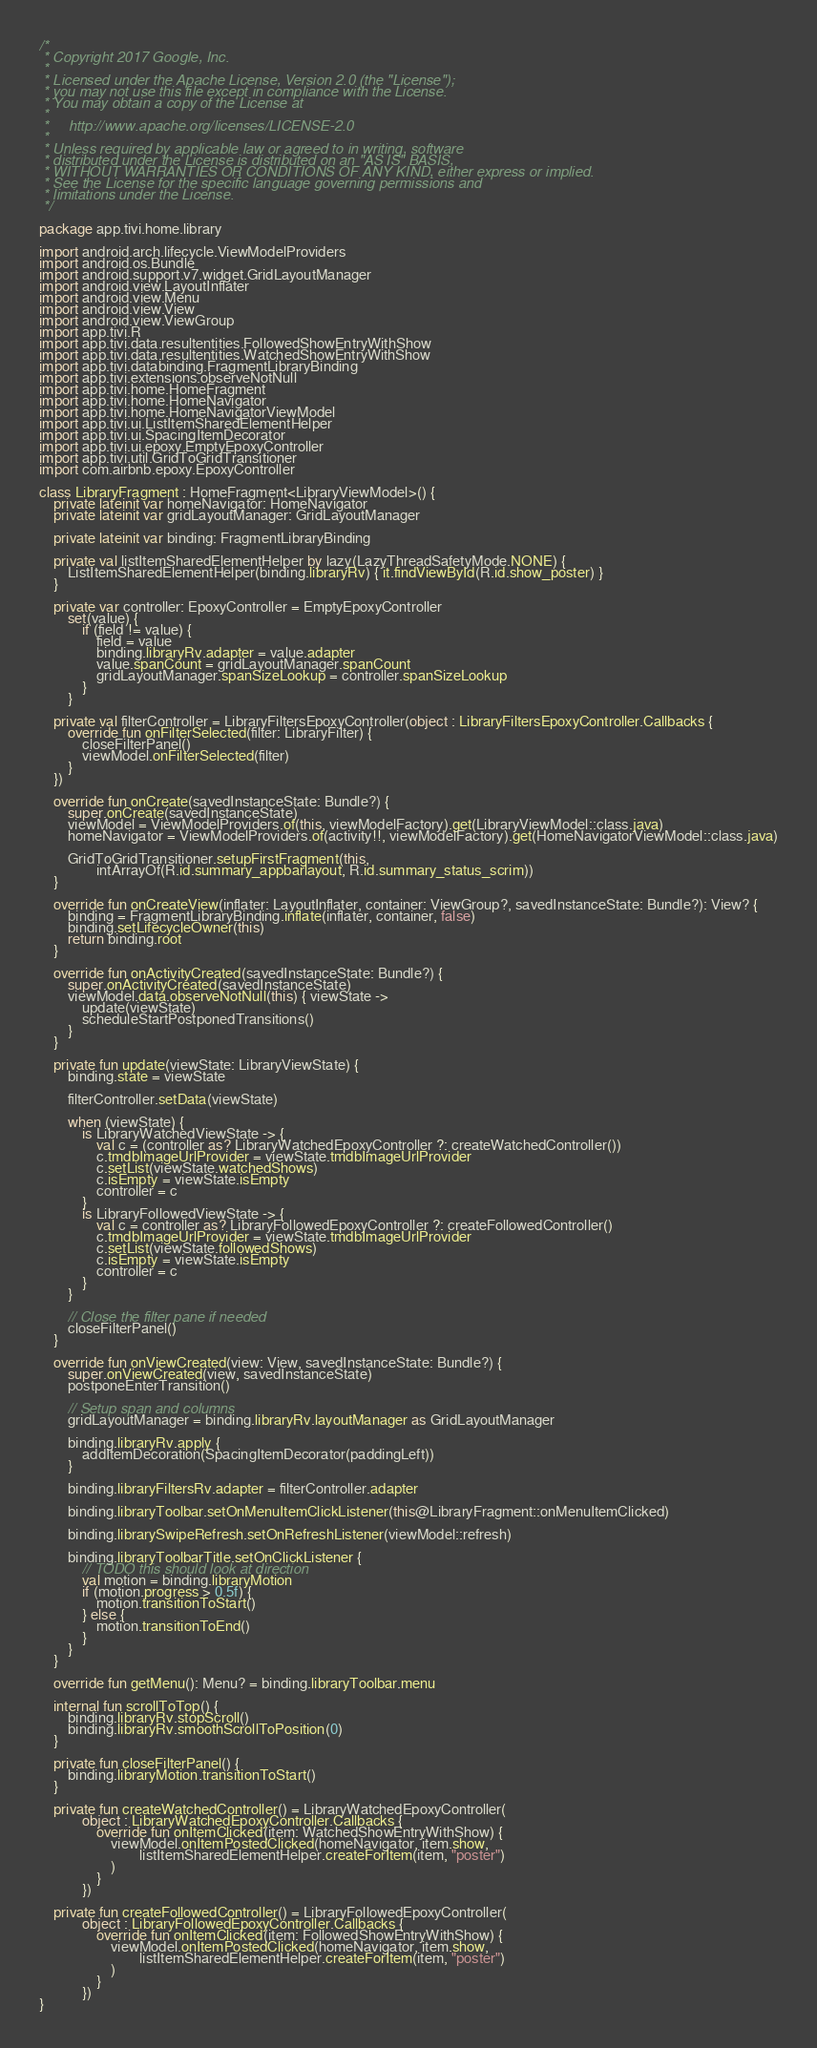<code> <loc_0><loc_0><loc_500><loc_500><_Kotlin_>/*
 * Copyright 2017 Google, Inc.
 *
 * Licensed under the Apache License, Version 2.0 (the "License");
 * you may not use this file except in compliance with the License.
 * You may obtain a copy of the License at
 *
 *     http://www.apache.org/licenses/LICENSE-2.0
 *
 * Unless required by applicable law or agreed to in writing, software
 * distributed under the License is distributed on an "AS IS" BASIS,
 * WITHOUT WARRANTIES OR CONDITIONS OF ANY KIND, either express or implied.
 * See the License for the specific language governing permissions and
 * limitations under the License.
 */

package app.tivi.home.library

import android.arch.lifecycle.ViewModelProviders
import android.os.Bundle
import android.support.v7.widget.GridLayoutManager
import android.view.LayoutInflater
import android.view.Menu
import android.view.View
import android.view.ViewGroup
import app.tivi.R
import app.tivi.data.resultentities.FollowedShowEntryWithShow
import app.tivi.data.resultentities.WatchedShowEntryWithShow
import app.tivi.databinding.FragmentLibraryBinding
import app.tivi.extensions.observeNotNull
import app.tivi.home.HomeFragment
import app.tivi.home.HomeNavigator
import app.tivi.home.HomeNavigatorViewModel
import app.tivi.ui.ListItemSharedElementHelper
import app.tivi.ui.SpacingItemDecorator
import app.tivi.ui.epoxy.EmptyEpoxyController
import app.tivi.util.GridToGridTransitioner
import com.airbnb.epoxy.EpoxyController

class LibraryFragment : HomeFragment<LibraryViewModel>() {
    private lateinit var homeNavigator: HomeNavigator
    private lateinit var gridLayoutManager: GridLayoutManager

    private lateinit var binding: FragmentLibraryBinding

    private val listItemSharedElementHelper by lazy(LazyThreadSafetyMode.NONE) {
        ListItemSharedElementHelper(binding.libraryRv) { it.findViewById(R.id.show_poster) }
    }

    private var controller: EpoxyController = EmptyEpoxyController
        set(value) {
            if (field != value) {
                field = value
                binding.libraryRv.adapter = value.adapter
                value.spanCount = gridLayoutManager.spanCount
                gridLayoutManager.spanSizeLookup = controller.spanSizeLookup
            }
        }

    private val filterController = LibraryFiltersEpoxyController(object : LibraryFiltersEpoxyController.Callbacks {
        override fun onFilterSelected(filter: LibraryFilter) {
            closeFilterPanel()
            viewModel.onFilterSelected(filter)
        }
    })

    override fun onCreate(savedInstanceState: Bundle?) {
        super.onCreate(savedInstanceState)
        viewModel = ViewModelProviders.of(this, viewModelFactory).get(LibraryViewModel::class.java)
        homeNavigator = ViewModelProviders.of(activity!!, viewModelFactory).get(HomeNavigatorViewModel::class.java)

        GridToGridTransitioner.setupFirstFragment(this,
                intArrayOf(R.id.summary_appbarlayout, R.id.summary_status_scrim))
    }

    override fun onCreateView(inflater: LayoutInflater, container: ViewGroup?, savedInstanceState: Bundle?): View? {
        binding = FragmentLibraryBinding.inflate(inflater, container, false)
        binding.setLifecycleOwner(this)
        return binding.root
    }

    override fun onActivityCreated(savedInstanceState: Bundle?) {
        super.onActivityCreated(savedInstanceState)
        viewModel.data.observeNotNull(this) { viewState ->
            update(viewState)
            scheduleStartPostponedTransitions()
        }
    }

    private fun update(viewState: LibraryViewState) {
        binding.state = viewState

        filterController.setData(viewState)

        when (viewState) {
            is LibraryWatchedViewState -> {
                val c = (controller as? LibraryWatchedEpoxyController ?: createWatchedController())
                c.tmdbImageUrlProvider = viewState.tmdbImageUrlProvider
                c.setList(viewState.watchedShows)
                c.isEmpty = viewState.isEmpty
                controller = c
            }
            is LibraryFollowedViewState -> {
                val c = controller as? LibraryFollowedEpoxyController ?: createFollowedController()
                c.tmdbImageUrlProvider = viewState.tmdbImageUrlProvider
                c.setList(viewState.followedShows)
                c.isEmpty = viewState.isEmpty
                controller = c
            }
        }

        // Close the filter pane if needed
        closeFilterPanel()
    }

    override fun onViewCreated(view: View, savedInstanceState: Bundle?) {
        super.onViewCreated(view, savedInstanceState)
        postponeEnterTransition()

        // Setup span and columns
        gridLayoutManager = binding.libraryRv.layoutManager as GridLayoutManager

        binding.libraryRv.apply {
            addItemDecoration(SpacingItemDecorator(paddingLeft))
        }

        binding.libraryFiltersRv.adapter = filterController.adapter

        binding.libraryToolbar.setOnMenuItemClickListener(this@LibraryFragment::onMenuItemClicked)

        binding.librarySwipeRefresh.setOnRefreshListener(viewModel::refresh)

        binding.libraryToolbarTitle.setOnClickListener {
            // TODO this should look at direction
            val motion = binding.libraryMotion
            if (motion.progress > 0.5f) {
                motion.transitionToStart()
            } else {
                motion.transitionToEnd()
            }
        }
    }

    override fun getMenu(): Menu? = binding.libraryToolbar.menu

    internal fun scrollToTop() {
        binding.libraryRv.stopScroll()
        binding.libraryRv.smoothScrollToPosition(0)
    }

    private fun closeFilterPanel() {
        binding.libraryMotion.transitionToStart()
    }

    private fun createWatchedController() = LibraryWatchedEpoxyController(
            object : LibraryWatchedEpoxyController.Callbacks {
                override fun onItemClicked(item: WatchedShowEntryWithShow) {
                    viewModel.onItemPostedClicked(homeNavigator, item.show,
                            listItemSharedElementHelper.createForItem(item, "poster")
                    )
                }
            })

    private fun createFollowedController() = LibraryFollowedEpoxyController(
            object : LibraryFollowedEpoxyController.Callbacks {
                override fun onItemClicked(item: FollowedShowEntryWithShow) {
                    viewModel.onItemPostedClicked(homeNavigator, item.show,
                            listItemSharedElementHelper.createForItem(item, "poster")
                    )
                }
            })
}
</code> 